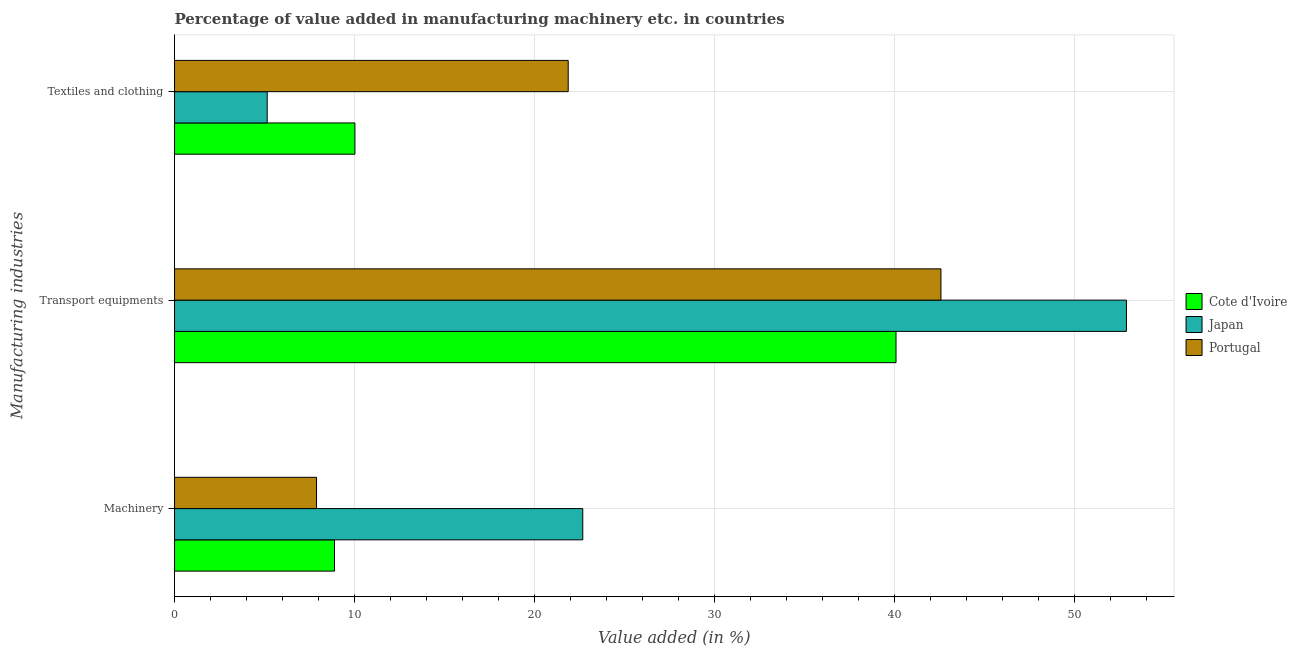Are the number of bars per tick equal to the number of legend labels?
Provide a succinct answer. Yes. Are the number of bars on each tick of the Y-axis equal?
Your answer should be very brief. Yes. What is the label of the 2nd group of bars from the top?
Make the answer very short. Transport equipments. What is the value added in manufacturing transport equipments in Portugal?
Provide a short and direct response. 42.57. Across all countries, what is the maximum value added in manufacturing machinery?
Give a very brief answer. 22.68. Across all countries, what is the minimum value added in manufacturing machinery?
Make the answer very short. 7.89. In which country was the value added in manufacturing machinery maximum?
Keep it short and to the point. Japan. In which country was the value added in manufacturing transport equipments minimum?
Keep it short and to the point. Cote d'Ivoire. What is the total value added in manufacturing transport equipments in the graph?
Your answer should be compact. 135.52. What is the difference between the value added in manufacturing transport equipments in Japan and that in Portugal?
Offer a terse response. 10.3. What is the difference between the value added in manufacturing machinery in Cote d'Ivoire and the value added in manufacturing transport equipments in Portugal?
Provide a short and direct response. -33.69. What is the average value added in manufacturing textile and clothing per country?
Offer a very short reply. 12.34. What is the difference between the value added in manufacturing machinery and value added in manufacturing transport equipments in Portugal?
Offer a terse response. -34.69. In how many countries, is the value added in manufacturing textile and clothing greater than 26 %?
Provide a short and direct response. 0. What is the ratio of the value added in manufacturing transport equipments in Cote d'Ivoire to that in Japan?
Offer a very short reply. 0.76. Is the value added in manufacturing machinery in Japan less than that in Cote d'Ivoire?
Give a very brief answer. No. Is the difference between the value added in manufacturing textile and clothing in Cote d'Ivoire and Portugal greater than the difference between the value added in manufacturing transport equipments in Cote d'Ivoire and Portugal?
Your answer should be very brief. No. What is the difference between the highest and the second highest value added in manufacturing machinery?
Provide a succinct answer. 13.79. What is the difference between the highest and the lowest value added in manufacturing machinery?
Provide a short and direct response. 14.79. In how many countries, is the value added in manufacturing machinery greater than the average value added in manufacturing machinery taken over all countries?
Make the answer very short. 1. Is the sum of the value added in manufacturing machinery in Japan and Cote d'Ivoire greater than the maximum value added in manufacturing textile and clothing across all countries?
Keep it short and to the point. Yes. What does the 3rd bar from the top in Transport equipments represents?
Make the answer very short. Cote d'Ivoire. What does the 1st bar from the bottom in Textiles and clothing represents?
Your answer should be compact. Cote d'Ivoire. How many bars are there?
Ensure brevity in your answer.  9. How many countries are there in the graph?
Your response must be concise. 3. Are the values on the major ticks of X-axis written in scientific E-notation?
Keep it short and to the point. No. Does the graph contain any zero values?
Offer a very short reply. No. Where does the legend appear in the graph?
Provide a succinct answer. Center right. How many legend labels are there?
Your response must be concise. 3. How are the legend labels stacked?
Provide a succinct answer. Vertical. What is the title of the graph?
Ensure brevity in your answer.  Percentage of value added in manufacturing machinery etc. in countries. Does "Faeroe Islands" appear as one of the legend labels in the graph?
Make the answer very short. No. What is the label or title of the X-axis?
Make the answer very short. Value added (in %). What is the label or title of the Y-axis?
Your answer should be compact. Manufacturing industries. What is the Value added (in %) of Cote d'Ivoire in Machinery?
Give a very brief answer. 8.88. What is the Value added (in %) of Japan in Machinery?
Give a very brief answer. 22.68. What is the Value added (in %) in Portugal in Machinery?
Offer a terse response. 7.89. What is the Value added (in %) in Cote d'Ivoire in Transport equipments?
Provide a short and direct response. 40.08. What is the Value added (in %) of Japan in Transport equipments?
Keep it short and to the point. 52.88. What is the Value added (in %) in Portugal in Transport equipments?
Your answer should be compact. 42.57. What is the Value added (in %) in Cote d'Ivoire in Textiles and clothing?
Provide a short and direct response. 10.02. What is the Value added (in %) of Japan in Textiles and clothing?
Keep it short and to the point. 5.15. What is the Value added (in %) in Portugal in Textiles and clothing?
Make the answer very short. 21.87. Across all Manufacturing industries, what is the maximum Value added (in %) in Cote d'Ivoire?
Provide a succinct answer. 40.08. Across all Manufacturing industries, what is the maximum Value added (in %) of Japan?
Give a very brief answer. 52.88. Across all Manufacturing industries, what is the maximum Value added (in %) in Portugal?
Your response must be concise. 42.57. Across all Manufacturing industries, what is the minimum Value added (in %) of Cote d'Ivoire?
Keep it short and to the point. 8.88. Across all Manufacturing industries, what is the minimum Value added (in %) of Japan?
Offer a terse response. 5.15. Across all Manufacturing industries, what is the minimum Value added (in %) in Portugal?
Give a very brief answer. 7.89. What is the total Value added (in %) of Cote d'Ivoire in the graph?
Your response must be concise. 58.98. What is the total Value added (in %) in Japan in the graph?
Ensure brevity in your answer.  80.7. What is the total Value added (in %) of Portugal in the graph?
Give a very brief answer. 72.33. What is the difference between the Value added (in %) of Cote d'Ivoire in Machinery and that in Transport equipments?
Keep it short and to the point. -31.19. What is the difference between the Value added (in %) in Japan in Machinery and that in Transport equipments?
Offer a terse response. -30.2. What is the difference between the Value added (in %) of Portugal in Machinery and that in Transport equipments?
Your answer should be compact. -34.69. What is the difference between the Value added (in %) of Cote d'Ivoire in Machinery and that in Textiles and clothing?
Provide a short and direct response. -1.13. What is the difference between the Value added (in %) in Japan in Machinery and that in Textiles and clothing?
Provide a short and direct response. 17.53. What is the difference between the Value added (in %) of Portugal in Machinery and that in Textiles and clothing?
Give a very brief answer. -13.98. What is the difference between the Value added (in %) in Cote d'Ivoire in Transport equipments and that in Textiles and clothing?
Your answer should be compact. 30.06. What is the difference between the Value added (in %) of Japan in Transport equipments and that in Textiles and clothing?
Give a very brief answer. 47.73. What is the difference between the Value added (in %) in Portugal in Transport equipments and that in Textiles and clothing?
Ensure brevity in your answer.  20.71. What is the difference between the Value added (in %) of Cote d'Ivoire in Machinery and the Value added (in %) of Japan in Transport equipments?
Provide a succinct answer. -43.99. What is the difference between the Value added (in %) of Cote d'Ivoire in Machinery and the Value added (in %) of Portugal in Transport equipments?
Your answer should be very brief. -33.69. What is the difference between the Value added (in %) in Japan in Machinery and the Value added (in %) in Portugal in Transport equipments?
Your answer should be very brief. -19.9. What is the difference between the Value added (in %) in Cote d'Ivoire in Machinery and the Value added (in %) in Japan in Textiles and clothing?
Provide a short and direct response. 3.74. What is the difference between the Value added (in %) of Cote d'Ivoire in Machinery and the Value added (in %) of Portugal in Textiles and clothing?
Make the answer very short. -12.98. What is the difference between the Value added (in %) in Japan in Machinery and the Value added (in %) in Portugal in Textiles and clothing?
Provide a succinct answer. 0.81. What is the difference between the Value added (in %) of Cote d'Ivoire in Transport equipments and the Value added (in %) of Japan in Textiles and clothing?
Your answer should be compact. 34.93. What is the difference between the Value added (in %) in Cote d'Ivoire in Transport equipments and the Value added (in %) in Portugal in Textiles and clothing?
Make the answer very short. 18.21. What is the difference between the Value added (in %) of Japan in Transport equipments and the Value added (in %) of Portugal in Textiles and clothing?
Your answer should be compact. 31.01. What is the average Value added (in %) of Cote d'Ivoire per Manufacturing industries?
Provide a succinct answer. 19.66. What is the average Value added (in %) of Japan per Manufacturing industries?
Keep it short and to the point. 26.9. What is the average Value added (in %) in Portugal per Manufacturing industries?
Your answer should be very brief. 24.11. What is the difference between the Value added (in %) of Cote d'Ivoire and Value added (in %) of Japan in Machinery?
Offer a very short reply. -13.79. What is the difference between the Value added (in %) of Cote d'Ivoire and Value added (in %) of Portugal in Machinery?
Your response must be concise. 1. What is the difference between the Value added (in %) in Japan and Value added (in %) in Portugal in Machinery?
Give a very brief answer. 14.79. What is the difference between the Value added (in %) of Cote d'Ivoire and Value added (in %) of Japan in Transport equipments?
Provide a succinct answer. -12.8. What is the difference between the Value added (in %) in Cote d'Ivoire and Value added (in %) in Portugal in Transport equipments?
Your response must be concise. -2.5. What is the difference between the Value added (in %) of Japan and Value added (in %) of Portugal in Transport equipments?
Offer a very short reply. 10.3. What is the difference between the Value added (in %) in Cote d'Ivoire and Value added (in %) in Japan in Textiles and clothing?
Ensure brevity in your answer.  4.87. What is the difference between the Value added (in %) of Cote d'Ivoire and Value added (in %) of Portugal in Textiles and clothing?
Offer a very short reply. -11.85. What is the difference between the Value added (in %) of Japan and Value added (in %) of Portugal in Textiles and clothing?
Give a very brief answer. -16.72. What is the ratio of the Value added (in %) of Cote d'Ivoire in Machinery to that in Transport equipments?
Give a very brief answer. 0.22. What is the ratio of the Value added (in %) in Japan in Machinery to that in Transport equipments?
Ensure brevity in your answer.  0.43. What is the ratio of the Value added (in %) of Portugal in Machinery to that in Transport equipments?
Make the answer very short. 0.19. What is the ratio of the Value added (in %) of Cote d'Ivoire in Machinery to that in Textiles and clothing?
Give a very brief answer. 0.89. What is the ratio of the Value added (in %) of Japan in Machinery to that in Textiles and clothing?
Keep it short and to the point. 4.41. What is the ratio of the Value added (in %) of Portugal in Machinery to that in Textiles and clothing?
Provide a succinct answer. 0.36. What is the ratio of the Value added (in %) of Cote d'Ivoire in Transport equipments to that in Textiles and clothing?
Offer a very short reply. 4. What is the ratio of the Value added (in %) of Japan in Transport equipments to that in Textiles and clothing?
Provide a short and direct response. 10.27. What is the ratio of the Value added (in %) in Portugal in Transport equipments to that in Textiles and clothing?
Your answer should be compact. 1.95. What is the difference between the highest and the second highest Value added (in %) of Cote d'Ivoire?
Offer a terse response. 30.06. What is the difference between the highest and the second highest Value added (in %) of Japan?
Provide a short and direct response. 30.2. What is the difference between the highest and the second highest Value added (in %) in Portugal?
Offer a terse response. 20.71. What is the difference between the highest and the lowest Value added (in %) of Cote d'Ivoire?
Offer a very short reply. 31.19. What is the difference between the highest and the lowest Value added (in %) in Japan?
Offer a very short reply. 47.73. What is the difference between the highest and the lowest Value added (in %) in Portugal?
Provide a succinct answer. 34.69. 